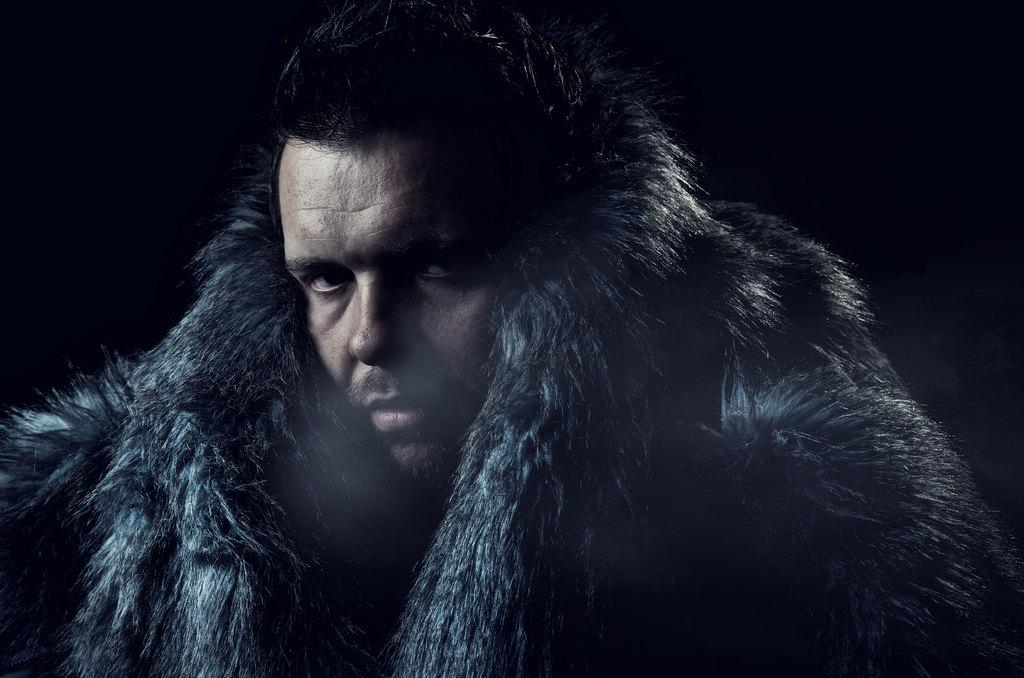Who or what is the main subject of the image? There is a person in the image. What is the person wearing? The person is wearing an object. Can you describe the background of the image? The background of the image is dark. What type of condition is the band experiencing in the image? There is no band present in the image, so it is not possible to determine any conditions they might be experiencing. 